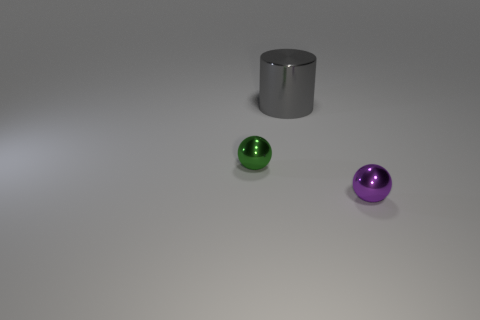Add 2 small brown rubber blocks. How many objects exist? 5 Subtract all spheres. How many objects are left? 1 Add 2 tiny purple shiny objects. How many tiny purple shiny objects exist? 3 Subtract 0 brown balls. How many objects are left? 3 Subtract all big shiny cylinders. Subtract all large shiny objects. How many objects are left? 1 Add 2 tiny metal balls. How many tiny metal balls are left? 4 